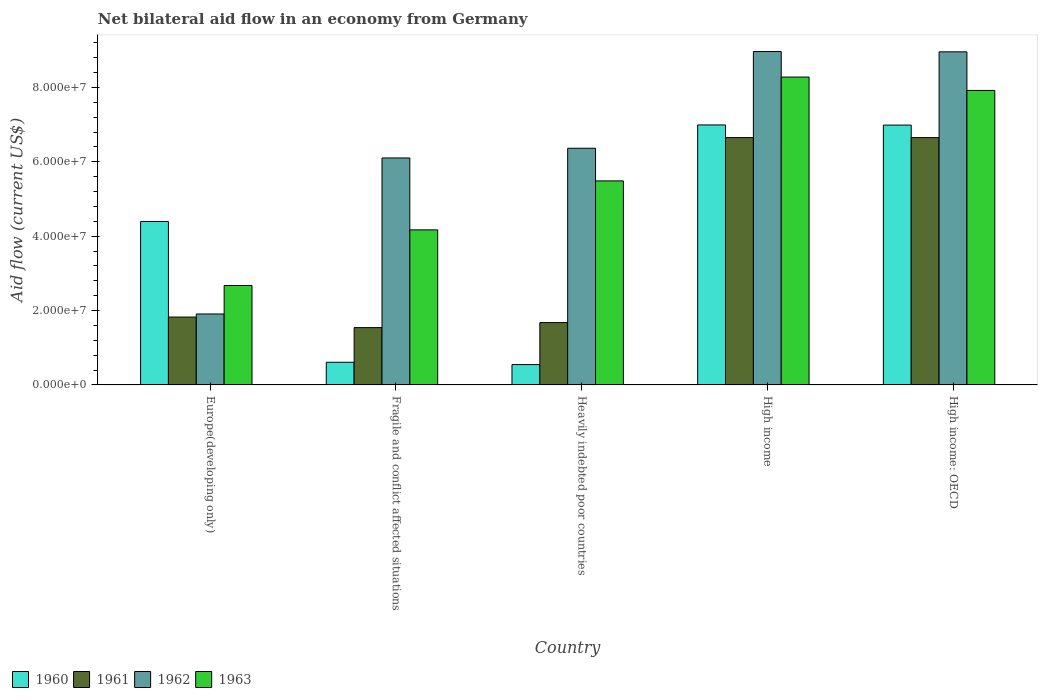How many different coloured bars are there?
Your response must be concise. 4. Are the number of bars on each tick of the X-axis equal?
Keep it short and to the point. Yes. How many bars are there on the 1st tick from the left?
Provide a short and direct response. 4. How many bars are there on the 3rd tick from the right?
Your answer should be compact. 4. What is the label of the 1st group of bars from the left?
Offer a terse response. Europe(developing only). What is the net bilateral aid flow in 1961 in High income: OECD?
Your answer should be compact. 6.65e+07. Across all countries, what is the maximum net bilateral aid flow in 1963?
Your response must be concise. 8.28e+07. Across all countries, what is the minimum net bilateral aid flow in 1963?
Give a very brief answer. 2.67e+07. In which country was the net bilateral aid flow in 1963 maximum?
Make the answer very short. High income. In which country was the net bilateral aid flow in 1960 minimum?
Your answer should be very brief. Heavily indebted poor countries. What is the total net bilateral aid flow in 1960 in the graph?
Provide a short and direct response. 1.95e+08. What is the difference between the net bilateral aid flow in 1961 in High income and that in High income: OECD?
Provide a short and direct response. 0. What is the difference between the net bilateral aid flow in 1960 in Europe(developing only) and the net bilateral aid flow in 1962 in High income?
Offer a terse response. -4.57e+07. What is the average net bilateral aid flow in 1962 per country?
Your answer should be compact. 6.46e+07. What is the difference between the net bilateral aid flow of/in 1963 and net bilateral aid flow of/in 1961 in Fragile and conflict affected situations?
Provide a short and direct response. 2.63e+07. In how many countries, is the net bilateral aid flow in 1961 greater than 20000000 US$?
Ensure brevity in your answer.  2. What is the ratio of the net bilateral aid flow in 1962 in Heavily indebted poor countries to that in High income: OECD?
Provide a short and direct response. 0.71. What is the difference between the highest and the lowest net bilateral aid flow in 1963?
Keep it short and to the point. 5.61e+07. In how many countries, is the net bilateral aid flow in 1960 greater than the average net bilateral aid flow in 1960 taken over all countries?
Provide a short and direct response. 3. Is the sum of the net bilateral aid flow in 1962 in Heavily indebted poor countries and High income greater than the maximum net bilateral aid flow in 1960 across all countries?
Provide a succinct answer. Yes. Is it the case that in every country, the sum of the net bilateral aid flow in 1960 and net bilateral aid flow in 1962 is greater than the sum of net bilateral aid flow in 1963 and net bilateral aid flow in 1961?
Provide a succinct answer. Yes. What does the 4th bar from the left in Europe(developing only) represents?
Your answer should be very brief. 1963. What does the 3rd bar from the right in Fragile and conflict affected situations represents?
Make the answer very short. 1961. How many countries are there in the graph?
Offer a terse response. 5. Does the graph contain any zero values?
Offer a very short reply. No. How many legend labels are there?
Provide a short and direct response. 4. How are the legend labels stacked?
Your answer should be compact. Horizontal. What is the title of the graph?
Ensure brevity in your answer.  Net bilateral aid flow in an economy from Germany. Does "1998" appear as one of the legend labels in the graph?
Provide a succinct answer. No. What is the Aid flow (current US$) of 1960 in Europe(developing only)?
Your answer should be compact. 4.40e+07. What is the Aid flow (current US$) in 1961 in Europe(developing only)?
Provide a succinct answer. 1.82e+07. What is the Aid flow (current US$) in 1962 in Europe(developing only)?
Your answer should be very brief. 1.91e+07. What is the Aid flow (current US$) in 1963 in Europe(developing only)?
Offer a terse response. 2.67e+07. What is the Aid flow (current US$) in 1960 in Fragile and conflict affected situations?
Your answer should be compact. 6.09e+06. What is the Aid flow (current US$) in 1961 in Fragile and conflict affected situations?
Provide a succinct answer. 1.54e+07. What is the Aid flow (current US$) of 1962 in Fragile and conflict affected situations?
Ensure brevity in your answer.  6.10e+07. What is the Aid flow (current US$) in 1963 in Fragile and conflict affected situations?
Offer a terse response. 4.17e+07. What is the Aid flow (current US$) in 1960 in Heavily indebted poor countries?
Offer a terse response. 5.47e+06. What is the Aid flow (current US$) of 1961 in Heavily indebted poor countries?
Your response must be concise. 1.68e+07. What is the Aid flow (current US$) of 1962 in Heavily indebted poor countries?
Your answer should be very brief. 6.36e+07. What is the Aid flow (current US$) in 1963 in Heavily indebted poor countries?
Your response must be concise. 5.49e+07. What is the Aid flow (current US$) of 1960 in High income?
Ensure brevity in your answer.  6.99e+07. What is the Aid flow (current US$) in 1961 in High income?
Give a very brief answer. 6.65e+07. What is the Aid flow (current US$) of 1962 in High income?
Make the answer very short. 8.97e+07. What is the Aid flow (current US$) of 1963 in High income?
Provide a short and direct response. 8.28e+07. What is the Aid flow (current US$) of 1960 in High income: OECD?
Your answer should be very brief. 6.99e+07. What is the Aid flow (current US$) of 1961 in High income: OECD?
Offer a very short reply. 6.65e+07. What is the Aid flow (current US$) in 1962 in High income: OECD?
Your response must be concise. 8.96e+07. What is the Aid flow (current US$) in 1963 in High income: OECD?
Offer a very short reply. 7.92e+07. Across all countries, what is the maximum Aid flow (current US$) in 1960?
Offer a very short reply. 6.99e+07. Across all countries, what is the maximum Aid flow (current US$) in 1961?
Provide a succinct answer. 6.65e+07. Across all countries, what is the maximum Aid flow (current US$) of 1962?
Provide a succinct answer. 8.97e+07. Across all countries, what is the maximum Aid flow (current US$) in 1963?
Provide a short and direct response. 8.28e+07. Across all countries, what is the minimum Aid flow (current US$) of 1960?
Ensure brevity in your answer.  5.47e+06. Across all countries, what is the minimum Aid flow (current US$) in 1961?
Offer a terse response. 1.54e+07. Across all countries, what is the minimum Aid flow (current US$) of 1962?
Ensure brevity in your answer.  1.91e+07. Across all countries, what is the minimum Aid flow (current US$) in 1963?
Provide a short and direct response. 2.67e+07. What is the total Aid flow (current US$) of 1960 in the graph?
Your answer should be very brief. 1.95e+08. What is the total Aid flow (current US$) in 1961 in the graph?
Ensure brevity in your answer.  1.83e+08. What is the total Aid flow (current US$) in 1962 in the graph?
Give a very brief answer. 3.23e+08. What is the total Aid flow (current US$) in 1963 in the graph?
Provide a succinct answer. 2.85e+08. What is the difference between the Aid flow (current US$) of 1960 in Europe(developing only) and that in Fragile and conflict affected situations?
Keep it short and to the point. 3.79e+07. What is the difference between the Aid flow (current US$) in 1961 in Europe(developing only) and that in Fragile and conflict affected situations?
Keep it short and to the point. 2.84e+06. What is the difference between the Aid flow (current US$) in 1962 in Europe(developing only) and that in Fragile and conflict affected situations?
Provide a short and direct response. -4.20e+07. What is the difference between the Aid flow (current US$) of 1963 in Europe(developing only) and that in Fragile and conflict affected situations?
Provide a succinct answer. -1.50e+07. What is the difference between the Aid flow (current US$) of 1960 in Europe(developing only) and that in Heavily indebted poor countries?
Your response must be concise. 3.85e+07. What is the difference between the Aid flow (current US$) of 1961 in Europe(developing only) and that in Heavily indebted poor countries?
Offer a very short reply. 1.49e+06. What is the difference between the Aid flow (current US$) in 1962 in Europe(developing only) and that in Heavily indebted poor countries?
Keep it short and to the point. -4.46e+07. What is the difference between the Aid flow (current US$) of 1963 in Europe(developing only) and that in Heavily indebted poor countries?
Offer a terse response. -2.81e+07. What is the difference between the Aid flow (current US$) of 1960 in Europe(developing only) and that in High income?
Your response must be concise. -2.60e+07. What is the difference between the Aid flow (current US$) in 1961 in Europe(developing only) and that in High income?
Make the answer very short. -4.83e+07. What is the difference between the Aid flow (current US$) of 1962 in Europe(developing only) and that in High income?
Keep it short and to the point. -7.06e+07. What is the difference between the Aid flow (current US$) of 1963 in Europe(developing only) and that in High income?
Your answer should be compact. -5.61e+07. What is the difference between the Aid flow (current US$) in 1960 in Europe(developing only) and that in High income: OECD?
Make the answer very short. -2.59e+07. What is the difference between the Aid flow (current US$) of 1961 in Europe(developing only) and that in High income: OECD?
Ensure brevity in your answer.  -4.83e+07. What is the difference between the Aid flow (current US$) in 1962 in Europe(developing only) and that in High income: OECD?
Make the answer very short. -7.05e+07. What is the difference between the Aid flow (current US$) of 1963 in Europe(developing only) and that in High income: OECD?
Your response must be concise. -5.25e+07. What is the difference between the Aid flow (current US$) of 1960 in Fragile and conflict affected situations and that in Heavily indebted poor countries?
Provide a short and direct response. 6.20e+05. What is the difference between the Aid flow (current US$) in 1961 in Fragile and conflict affected situations and that in Heavily indebted poor countries?
Your answer should be compact. -1.35e+06. What is the difference between the Aid flow (current US$) of 1962 in Fragile and conflict affected situations and that in Heavily indebted poor countries?
Your response must be concise. -2.61e+06. What is the difference between the Aid flow (current US$) in 1963 in Fragile and conflict affected situations and that in Heavily indebted poor countries?
Offer a very short reply. -1.32e+07. What is the difference between the Aid flow (current US$) of 1960 in Fragile and conflict affected situations and that in High income?
Provide a succinct answer. -6.38e+07. What is the difference between the Aid flow (current US$) of 1961 in Fragile and conflict affected situations and that in High income?
Give a very brief answer. -5.11e+07. What is the difference between the Aid flow (current US$) in 1962 in Fragile and conflict affected situations and that in High income?
Your answer should be compact. -2.86e+07. What is the difference between the Aid flow (current US$) in 1963 in Fragile and conflict affected situations and that in High income?
Offer a terse response. -4.11e+07. What is the difference between the Aid flow (current US$) in 1960 in Fragile and conflict affected situations and that in High income: OECD?
Offer a terse response. -6.38e+07. What is the difference between the Aid flow (current US$) in 1961 in Fragile and conflict affected situations and that in High income: OECD?
Offer a very short reply. -5.11e+07. What is the difference between the Aid flow (current US$) in 1962 in Fragile and conflict affected situations and that in High income: OECD?
Your response must be concise. -2.85e+07. What is the difference between the Aid flow (current US$) in 1963 in Fragile and conflict affected situations and that in High income: OECD?
Provide a succinct answer. -3.75e+07. What is the difference between the Aid flow (current US$) of 1960 in Heavily indebted poor countries and that in High income?
Ensure brevity in your answer.  -6.44e+07. What is the difference between the Aid flow (current US$) of 1961 in Heavily indebted poor countries and that in High income?
Provide a succinct answer. -4.98e+07. What is the difference between the Aid flow (current US$) in 1962 in Heavily indebted poor countries and that in High income?
Give a very brief answer. -2.60e+07. What is the difference between the Aid flow (current US$) in 1963 in Heavily indebted poor countries and that in High income?
Your answer should be very brief. -2.79e+07. What is the difference between the Aid flow (current US$) of 1960 in Heavily indebted poor countries and that in High income: OECD?
Your answer should be very brief. -6.44e+07. What is the difference between the Aid flow (current US$) of 1961 in Heavily indebted poor countries and that in High income: OECD?
Make the answer very short. -4.98e+07. What is the difference between the Aid flow (current US$) in 1962 in Heavily indebted poor countries and that in High income: OECD?
Your answer should be compact. -2.59e+07. What is the difference between the Aid flow (current US$) of 1963 in Heavily indebted poor countries and that in High income: OECD?
Provide a short and direct response. -2.43e+07. What is the difference between the Aid flow (current US$) in 1960 in High income and that in High income: OECD?
Offer a terse response. 4.00e+04. What is the difference between the Aid flow (current US$) of 1963 in High income and that in High income: OECD?
Your response must be concise. 3.60e+06. What is the difference between the Aid flow (current US$) of 1960 in Europe(developing only) and the Aid flow (current US$) of 1961 in Fragile and conflict affected situations?
Ensure brevity in your answer.  2.86e+07. What is the difference between the Aid flow (current US$) in 1960 in Europe(developing only) and the Aid flow (current US$) in 1962 in Fragile and conflict affected situations?
Your answer should be very brief. -1.71e+07. What is the difference between the Aid flow (current US$) of 1960 in Europe(developing only) and the Aid flow (current US$) of 1963 in Fragile and conflict affected situations?
Provide a succinct answer. 2.26e+06. What is the difference between the Aid flow (current US$) of 1961 in Europe(developing only) and the Aid flow (current US$) of 1962 in Fragile and conflict affected situations?
Provide a short and direct response. -4.28e+07. What is the difference between the Aid flow (current US$) of 1961 in Europe(developing only) and the Aid flow (current US$) of 1963 in Fragile and conflict affected situations?
Keep it short and to the point. -2.34e+07. What is the difference between the Aid flow (current US$) of 1962 in Europe(developing only) and the Aid flow (current US$) of 1963 in Fragile and conflict affected situations?
Give a very brief answer. -2.26e+07. What is the difference between the Aid flow (current US$) in 1960 in Europe(developing only) and the Aid flow (current US$) in 1961 in Heavily indebted poor countries?
Offer a very short reply. 2.72e+07. What is the difference between the Aid flow (current US$) in 1960 in Europe(developing only) and the Aid flow (current US$) in 1962 in Heavily indebted poor countries?
Your response must be concise. -1.97e+07. What is the difference between the Aid flow (current US$) in 1960 in Europe(developing only) and the Aid flow (current US$) in 1963 in Heavily indebted poor countries?
Provide a short and direct response. -1.09e+07. What is the difference between the Aid flow (current US$) of 1961 in Europe(developing only) and the Aid flow (current US$) of 1962 in Heavily indebted poor countries?
Provide a succinct answer. -4.54e+07. What is the difference between the Aid flow (current US$) in 1961 in Europe(developing only) and the Aid flow (current US$) in 1963 in Heavily indebted poor countries?
Your response must be concise. -3.66e+07. What is the difference between the Aid flow (current US$) in 1962 in Europe(developing only) and the Aid flow (current US$) in 1963 in Heavily indebted poor countries?
Ensure brevity in your answer.  -3.58e+07. What is the difference between the Aid flow (current US$) of 1960 in Europe(developing only) and the Aid flow (current US$) of 1961 in High income?
Your response must be concise. -2.26e+07. What is the difference between the Aid flow (current US$) in 1960 in Europe(developing only) and the Aid flow (current US$) in 1962 in High income?
Keep it short and to the point. -4.57e+07. What is the difference between the Aid flow (current US$) in 1960 in Europe(developing only) and the Aid flow (current US$) in 1963 in High income?
Offer a terse response. -3.88e+07. What is the difference between the Aid flow (current US$) of 1961 in Europe(developing only) and the Aid flow (current US$) of 1962 in High income?
Offer a very short reply. -7.14e+07. What is the difference between the Aid flow (current US$) in 1961 in Europe(developing only) and the Aid flow (current US$) in 1963 in High income?
Your answer should be compact. -6.46e+07. What is the difference between the Aid flow (current US$) in 1962 in Europe(developing only) and the Aid flow (current US$) in 1963 in High income?
Your response must be concise. -6.37e+07. What is the difference between the Aid flow (current US$) in 1960 in Europe(developing only) and the Aid flow (current US$) in 1961 in High income: OECD?
Ensure brevity in your answer.  -2.26e+07. What is the difference between the Aid flow (current US$) in 1960 in Europe(developing only) and the Aid flow (current US$) in 1962 in High income: OECD?
Provide a short and direct response. -4.56e+07. What is the difference between the Aid flow (current US$) in 1960 in Europe(developing only) and the Aid flow (current US$) in 1963 in High income: OECD?
Your answer should be compact. -3.52e+07. What is the difference between the Aid flow (current US$) of 1961 in Europe(developing only) and the Aid flow (current US$) of 1962 in High income: OECD?
Your answer should be very brief. -7.13e+07. What is the difference between the Aid flow (current US$) of 1961 in Europe(developing only) and the Aid flow (current US$) of 1963 in High income: OECD?
Your answer should be compact. -6.10e+07. What is the difference between the Aid flow (current US$) in 1962 in Europe(developing only) and the Aid flow (current US$) in 1963 in High income: OECD?
Ensure brevity in your answer.  -6.01e+07. What is the difference between the Aid flow (current US$) of 1960 in Fragile and conflict affected situations and the Aid flow (current US$) of 1961 in Heavily indebted poor countries?
Offer a terse response. -1.07e+07. What is the difference between the Aid flow (current US$) in 1960 in Fragile and conflict affected situations and the Aid flow (current US$) in 1962 in Heavily indebted poor countries?
Offer a terse response. -5.76e+07. What is the difference between the Aid flow (current US$) in 1960 in Fragile and conflict affected situations and the Aid flow (current US$) in 1963 in Heavily indebted poor countries?
Your response must be concise. -4.88e+07. What is the difference between the Aid flow (current US$) in 1961 in Fragile and conflict affected situations and the Aid flow (current US$) in 1962 in Heavily indebted poor countries?
Keep it short and to the point. -4.82e+07. What is the difference between the Aid flow (current US$) in 1961 in Fragile and conflict affected situations and the Aid flow (current US$) in 1963 in Heavily indebted poor countries?
Your answer should be very brief. -3.95e+07. What is the difference between the Aid flow (current US$) of 1962 in Fragile and conflict affected situations and the Aid flow (current US$) of 1963 in Heavily indebted poor countries?
Provide a short and direct response. 6.17e+06. What is the difference between the Aid flow (current US$) in 1960 in Fragile and conflict affected situations and the Aid flow (current US$) in 1961 in High income?
Your response must be concise. -6.04e+07. What is the difference between the Aid flow (current US$) in 1960 in Fragile and conflict affected situations and the Aid flow (current US$) in 1962 in High income?
Your response must be concise. -8.36e+07. What is the difference between the Aid flow (current US$) of 1960 in Fragile and conflict affected situations and the Aid flow (current US$) of 1963 in High income?
Provide a succinct answer. -7.67e+07. What is the difference between the Aid flow (current US$) in 1961 in Fragile and conflict affected situations and the Aid flow (current US$) in 1962 in High income?
Provide a succinct answer. -7.42e+07. What is the difference between the Aid flow (current US$) in 1961 in Fragile and conflict affected situations and the Aid flow (current US$) in 1963 in High income?
Your answer should be very brief. -6.74e+07. What is the difference between the Aid flow (current US$) in 1962 in Fragile and conflict affected situations and the Aid flow (current US$) in 1963 in High income?
Provide a succinct answer. -2.18e+07. What is the difference between the Aid flow (current US$) of 1960 in Fragile and conflict affected situations and the Aid flow (current US$) of 1961 in High income: OECD?
Provide a short and direct response. -6.04e+07. What is the difference between the Aid flow (current US$) of 1960 in Fragile and conflict affected situations and the Aid flow (current US$) of 1962 in High income: OECD?
Make the answer very short. -8.35e+07. What is the difference between the Aid flow (current US$) of 1960 in Fragile and conflict affected situations and the Aid flow (current US$) of 1963 in High income: OECD?
Provide a succinct answer. -7.31e+07. What is the difference between the Aid flow (current US$) of 1961 in Fragile and conflict affected situations and the Aid flow (current US$) of 1962 in High income: OECD?
Your answer should be compact. -7.42e+07. What is the difference between the Aid flow (current US$) in 1961 in Fragile and conflict affected situations and the Aid flow (current US$) in 1963 in High income: OECD?
Give a very brief answer. -6.38e+07. What is the difference between the Aid flow (current US$) in 1962 in Fragile and conflict affected situations and the Aid flow (current US$) in 1963 in High income: OECD?
Your answer should be compact. -1.82e+07. What is the difference between the Aid flow (current US$) in 1960 in Heavily indebted poor countries and the Aid flow (current US$) in 1961 in High income?
Keep it short and to the point. -6.10e+07. What is the difference between the Aid flow (current US$) in 1960 in Heavily indebted poor countries and the Aid flow (current US$) in 1962 in High income?
Provide a succinct answer. -8.42e+07. What is the difference between the Aid flow (current US$) of 1960 in Heavily indebted poor countries and the Aid flow (current US$) of 1963 in High income?
Provide a succinct answer. -7.73e+07. What is the difference between the Aid flow (current US$) of 1961 in Heavily indebted poor countries and the Aid flow (current US$) of 1962 in High income?
Keep it short and to the point. -7.29e+07. What is the difference between the Aid flow (current US$) in 1961 in Heavily indebted poor countries and the Aid flow (current US$) in 1963 in High income?
Provide a succinct answer. -6.60e+07. What is the difference between the Aid flow (current US$) in 1962 in Heavily indebted poor countries and the Aid flow (current US$) in 1963 in High income?
Keep it short and to the point. -1.92e+07. What is the difference between the Aid flow (current US$) of 1960 in Heavily indebted poor countries and the Aid flow (current US$) of 1961 in High income: OECD?
Your answer should be compact. -6.10e+07. What is the difference between the Aid flow (current US$) in 1960 in Heavily indebted poor countries and the Aid flow (current US$) in 1962 in High income: OECD?
Your answer should be compact. -8.41e+07. What is the difference between the Aid flow (current US$) in 1960 in Heavily indebted poor countries and the Aid flow (current US$) in 1963 in High income: OECD?
Your answer should be very brief. -7.37e+07. What is the difference between the Aid flow (current US$) in 1961 in Heavily indebted poor countries and the Aid flow (current US$) in 1962 in High income: OECD?
Provide a short and direct response. -7.28e+07. What is the difference between the Aid flow (current US$) of 1961 in Heavily indebted poor countries and the Aid flow (current US$) of 1963 in High income: OECD?
Your response must be concise. -6.24e+07. What is the difference between the Aid flow (current US$) in 1962 in Heavily indebted poor countries and the Aid flow (current US$) in 1963 in High income: OECD?
Provide a short and direct response. -1.56e+07. What is the difference between the Aid flow (current US$) of 1960 in High income and the Aid flow (current US$) of 1961 in High income: OECD?
Keep it short and to the point. 3.41e+06. What is the difference between the Aid flow (current US$) in 1960 in High income and the Aid flow (current US$) in 1962 in High income: OECD?
Your answer should be very brief. -1.97e+07. What is the difference between the Aid flow (current US$) of 1960 in High income and the Aid flow (current US$) of 1963 in High income: OECD?
Keep it short and to the point. -9.28e+06. What is the difference between the Aid flow (current US$) of 1961 in High income and the Aid flow (current US$) of 1962 in High income: OECD?
Ensure brevity in your answer.  -2.31e+07. What is the difference between the Aid flow (current US$) of 1961 in High income and the Aid flow (current US$) of 1963 in High income: OECD?
Give a very brief answer. -1.27e+07. What is the difference between the Aid flow (current US$) in 1962 in High income and the Aid flow (current US$) in 1963 in High income: OECD?
Ensure brevity in your answer.  1.05e+07. What is the average Aid flow (current US$) in 1960 per country?
Offer a very short reply. 3.91e+07. What is the average Aid flow (current US$) in 1961 per country?
Keep it short and to the point. 3.67e+07. What is the average Aid flow (current US$) in 1962 per country?
Provide a short and direct response. 6.46e+07. What is the average Aid flow (current US$) of 1963 per country?
Your response must be concise. 5.71e+07. What is the difference between the Aid flow (current US$) in 1960 and Aid flow (current US$) in 1961 in Europe(developing only)?
Ensure brevity in your answer.  2.57e+07. What is the difference between the Aid flow (current US$) in 1960 and Aid flow (current US$) in 1962 in Europe(developing only)?
Your answer should be compact. 2.49e+07. What is the difference between the Aid flow (current US$) of 1960 and Aid flow (current US$) of 1963 in Europe(developing only)?
Provide a short and direct response. 1.72e+07. What is the difference between the Aid flow (current US$) of 1961 and Aid flow (current US$) of 1962 in Europe(developing only)?
Your answer should be very brief. -8.30e+05. What is the difference between the Aid flow (current US$) of 1961 and Aid flow (current US$) of 1963 in Europe(developing only)?
Your response must be concise. -8.49e+06. What is the difference between the Aid flow (current US$) of 1962 and Aid flow (current US$) of 1963 in Europe(developing only)?
Ensure brevity in your answer.  -7.66e+06. What is the difference between the Aid flow (current US$) in 1960 and Aid flow (current US$) in 1961 in Fragile and conflict affected situations?
Provide a short and direct response. -9.32e+06. What is the difference between the Aid flow (current US$) of 1960 and Aid flow (current US$) of 1962 in Fragile and conflict affected situations?
Ensure brevity in your answer.  -5.50e+07. What is the difference between the Aid flow (current US$) in 1960 and Aid flow (current US$) in 1963 in Fragile and conflict affected situations?
Provide a succinct answer. -3.56e+07. What is the difference between the Aid flow (current US$) in 1961 and Aid flow (current US$) in 1962 in Fragile and conflict affected situations?
Your response must be concise. -4.56e+07. What is the difference between the Aid flow (current US$) of 1961 and Aid flow (current US$) of 1963 in Fragile and conflict affected situations?
Provide a short and direct response. -2.63e+07. What is the difference between the Aid flow (current US$) in 1962 and Aid flow (current US$) in 1963 in Fragile and conflict affected situations?
Keep it short and to the point. 1.93e+07. What is the difference between the Aid flow (current US$) in 1960 and Aid flow (current US$) in 1961 in Heavily indebted poor countries?
Provide a succinct answer. -1.13e+07. What is the difference between the Aid flow (current US$) of 1960 and Aid flow (current US$) of 1962 in Heavily indebted poor countries?
Ensure brevity in your answer.  -5.82e+07. What is the difference between the Aid flow (current US$) in 1960 and Aid flow (current US$) in 1963 in Heavily indebted poor countries?
Offer a terse response. -4.94e+07. What is the difference between the Aid flow (current US$) in 1961 and Aid flow (current US$) in 1962 in Heavily indebted poor countries?
Provide a succinct answer. -4.69e+07. What is the difference between the Aid flow (current US$) in 1961 and Aid flow (current US$) in 1963 in Heavily indebted poor countries?
Keep it short and to the point. -3.81e+07. What is the difference between the Aid flow (current US$) of 1962 and Aid flow (current US$) of 1963 in Heavily indebted poor countries?
Your response must be concise. 8.78e+06. What is the difference between the Aid flow (current US$) of 1960 and Aid flow (current US$) of 1961 in High income?
Provide a short and direct response. 3.41e+06. What is the difference between the Aid flow (current US$) of 1960 and Aid flow (current US$) of 1962 in High income?
Offer a very short reply. -1.97e+07. What is the difference between the Aid flow (current US$) of 1960 and Aid flow (current US$) of 1963 in High income?
Provide a succinct answer. -1.29e+07. What is the difference between the Aid flow (current US$) in 1961 and Aid flow (current US$) in 1962 in High income?
Make the answer very short. -2.32e+07. What is the difference between the Aid flow (current US$) of 1961 and Aid flow (current US$) of 1963 in High income?
Your response must be concise. -1.63e+07. What is the difference between the Aid flow (current US$) in 1962 and Aid flow (current US$) in 1963 in High income?
Ensure brevity in your answer.  6.86e+06. What is the difference between the Aid flow (current US$) of 1960 and Aid flow (current US$) of 1961 in High income: OECD?
Give a very brief answer. 3.37e+06. What is the difference between the Aid flow (current US$) of 1960 and Aid flow (current US$) of 1962 in High income: OECD?
Offer a terse response. -1.97e+07. What is the difference between the Aid flow (current US$) in 1960 and Aid flow (current US$) in 1963 in High income: OECD?
Your answer should be very brief. -9.32e+06. What is the difference between the Aid flow (current US$) in 1961 and Aid flow (current US$) in 1962 in High income: OECD?
Your answer should be very brief. -2.31e+07. What is the difference between the Aid flow (current US$) in 1961 and Aid flow (current US$) in 1963 in High income: OECD?
Make the answer very short. -1.27e+07. What is the difference between the Aid flow (current US$) of 1962 and Aid flow (current US$) of 1963 in High income: OECD?
Your answer should be compact. 1.04e+07. What is the ratio of the Aid flow (current US$) of 1960 in Europe(developing only) to that in Fragile and conflict affected situations?
Provide a short and direct response. 7.22. What is the ratio of the Aid flow (current US$) in 1961 in Europe(developing only) to that in Fragile and conflict affected situations?
Ensure brevity in your answer.  1.18. What is the ratio of the Aid flow (current US$) of 1962 in Europe(developing only) to that in Fragile and conflict affected situations?
Your response must be concise. 0.31. What is the ratio of the Aid flow (current US$) of 1963 in Europe(developing only) to that in Fragile and conflict affected situations?
Your answer should be compact. 0.64. What is the ratio of the Aid flow (current US$) of 1960 in Europe(developing only) to that in Heavily indebted poor countries?
Give a very brief answer. 8.04. What is the ratio of the Aid flow (current US$) in 1961 in Europe(developing only) to that in Heavily indebted poor countries?
Offer a terse response. 1.09. What is the ratio of the Aid flow (current US$) in 1962 in Europe(developing only) to that in Heavily indebted poor countries?
Ensure brevity in your answer.  0.3. What is the ratio of the Aid flow (current US$) of 1963 in Europe(developing only) to that in Heavily indebted poor countries?
Offer a terse response. 0.49. What is the ratio of the Aid flow (current US$) in 1960 in Europe(developing only) to that in High income?
Keep it short and to the point. 0.63. What is the ratio of the Aid flow (current US$) in 1961 in Europe(developing only) to that in High income?
Provide a short and direct response. 0.27. What is the ratio of the Aid flow (current US$) of 1962 in Europe(developing only) to that in High income?
Provide a succinct answer. 0.21. What is the ratio of the Aid flow (current US$) in 1963 in Europe(developing only) to that in High income?
Ensure brevity in your answer.  0.32. What is the ratio of the Aid flow (current US$) in 1960 in Europe(developing only) to that in High income: OECD?
Ensure brevity in your answer.  0.63. What is the ratio of the Aid flow (current US$) of 1961 in Europe(developing only) to that in High income: OECD?
Your response must be concise. 0.27. What is the ratio of the Aid flow (current US$) in 1962 in Europe(developing only) to that in High income: OECD?
Your answer should be very brief. 0.21. What is the ratio of the Aid flow (current US$) in 1963 in Europe(developing only) to that in High income: OECD?
Provide a succinct answer. 0.34. What is the ratio of the Aid flow (current US$) of 1960 in Fragile and conflict affected situations to that in Heavily indebted poor countries?
Offer a terse response. 1.11. What is the ratio of the Aid flow (current US$) in 1961 in Fragile and conflict affected situations to that in Heavily indebted poor countries?
Offer a terse response. 0.92. What is the ratio of the Aid flow (current US$) of 1963 in Fragile and conflict affected situations to that in Heavily indebted poor countries?
Provide a succinct answer. 0.76. What is the ratio of the Aid flow (current US$) in 1960 in Fragile and conflict affected situations to that in High income?
Provide a succinct answer. 0.09. What is the ratio of the Aid flow (current US$) in 1961 in Fragile and conflict affected situations to that in High income?
Offer a very short reply. 0.23. What is the ratio of the Aid flow (current US$) in 1962 in Fragile and conflict affected situations to that in High income?
Your response must be concise. 0.68. What is the ratio of the Aid flow (current US$) in 1963 in Fragile and conflict affected situations to that in High income?
Provide a succinct answer. 0.5. What is the ratio of the Aid flow (current US$) of 1960 in Fragile and conflict affected situations to that in High income: OECD?
Provide a succinct answer. 0.09. What is the ratio of the Aid flow (current US$) in 1961 in Fragile and conflict affected situations to that in High income: OECD?
Ensure brevity in your answer.  0.23. What is the ratio of the Aid flow (current US$) in 1962 in Fragile and conflict affected situations to that in High income: OECD?
Offer a very short reply. 0.68. What is the ratio of the Aid flow (current US$) of 1963 in Fragile and conflict affected situations to that in High income: OECD?
Provide a succinct answer. 0.53. What is the ratio of the Aid flow (current US$) of 1960 in Heavily indebted poor countries to that in High income?
Your answer should be compact. 0.08. What is the ratio of the Aid flow (current US$) of 1961 in Heavily indebted poor countries to that in High income?
Offer a terse response. 0.25. What is the ratio of the Aid flow (current US$) in 1962 in Heavily indebted poor countries to that in High income?
Provide a short and direct response. 0.71. What is the ratio of the Aid flow (current US$) of 1963 in Heavily indebted poor countries to that in High income?
Ensure brevity in your answer.  0.66. What is the ratio of the Aid flow (current US$) of 1960 in Heavily indebted poor countries to that in High income: OECD?
Your answer should be compact. 0.08. What is the ratio of the Aid flow (current US$) of 1961 in Heavily indebted poor countries to that in High income: OECD?
Give a very brief answer. 0.25. What is the ratio of the Aid flow (current US$) in 1962 in Heavily indebted poor countries to that in High income: OECD?
Keep it short and to the point. 0.71. What is the ratio of the Aid flow (current US$) in 1963 in Heavily indebted poor countries to that in High income: OECD?
Offer a terse response. 0.69. What is the ratio of the Aid flow (current US$) of 1960 in High income to that in High income: OECD?
Keep it short and to the point. 1. What is the ratio of the Aid flow (current US$) of 1963 in High income to that in High income: OECD?
Give a very brief answer. 1.05. What is the difference between the highest and the second highest Aid flow (current US$) of 1963?
Ensure brevity in your answer.  3.60e+06. What is the difference between the highest and the lowest Aid flow (current US$) in 1960?
Make the answer very short. 6.44e+07. What is the difference between the highest and the lowest Aid flow (current US$) of 1961?
Your response must be concise. 5.11e+07. What is the difference between the highest and the lowest Aid flow (current US$) of 1962?
Your answer should be compact. 7.06e+07. What is the difference between the highest and the lowest Aid flow (current US$) of 1963?
Keep it short and to the point. 5.61e+07. 